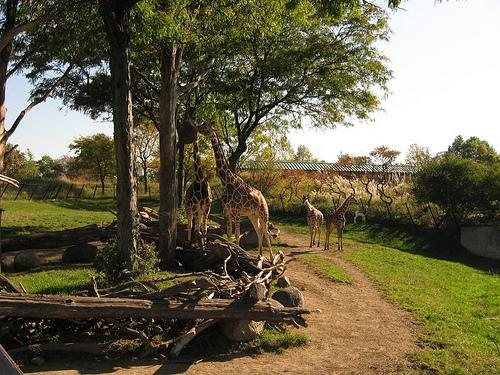Protected areas for these types of animals are known as what? Please explain your reasoning. wildlife reserves. This is a wildlife reserve for animals. 